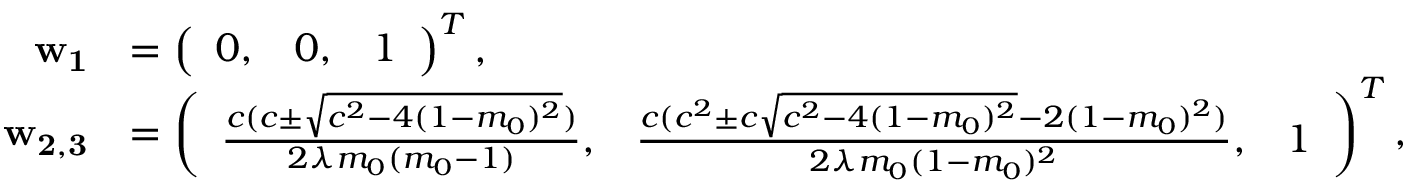<formula> <loc_0><loc_0><loc_500><loc_500>\begin{array} { r l } { w _ { 1 } } & { = \left ( \begin{array} { l l l } { 0 , } & { 0 , } & { 1 } \end{array} \right ) ^ { T } , } \\ { w _ { 2 , 3 } } & { = \left ( \begin{array} { l l l } { \frac { c ( c \pm \sqrt { c ^ { 2 } - 4 ( 1 - m _ { 0 } ) ^ { 2 } } ) } { 2 \lambda m _ { 0 } ( m _ { 0 } - 1 ) } , } & { \frac { c ( c ^ { 2 } \pm c \sqrt { c ^ { 2 } - 4 ( 1 - m _ { 0 } ) ^ { 2 } } - 2 ( 1 - m _ { 0 } ) ^ { 2 } ) } { 2 \lambda m _ { 0 } ( 1 - m _ { 0 } ) ^ { 2 } } , } & { 1 } \end{array} \right ) ^ { T } , } \end{array}</formula> 